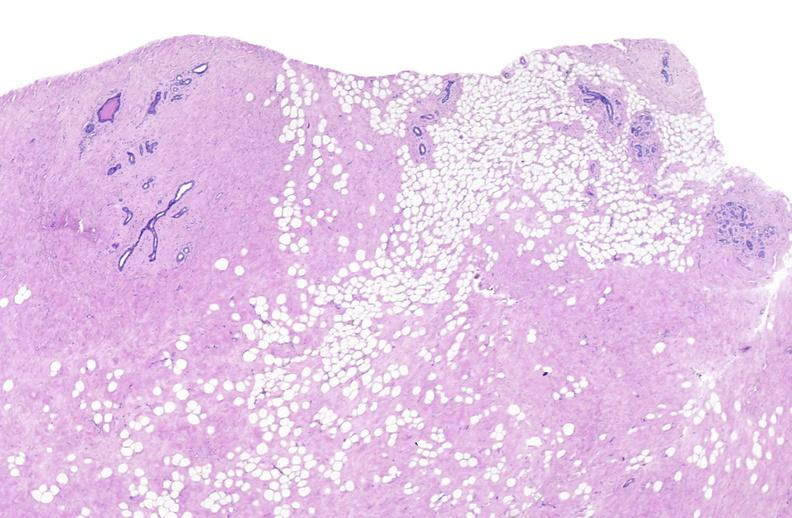where is this area in the body?
Answer the question using a single word or phrase. Breast 